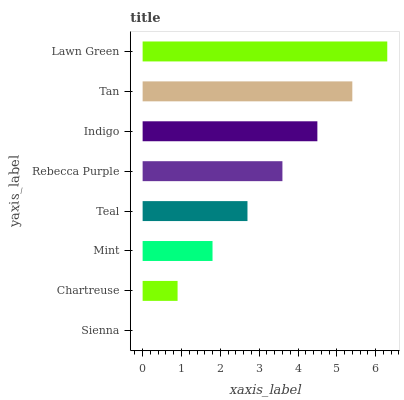Is Sienna the minimum?
Answer yes or no. Yes. Is Lawn Green the maximum?
Answer yes or no. Yes. Is Chartreuse the minimum?
Answer yes or no. No. Is Chartreuse the maximum?
Answer yes or no. No. Is Chartreuse greater than Sienna?
Answer yes or no. Yes. Is Sienna less than Chartreuse?
Answer yes or no. Yes. Is Sienna greater than Chartreuse?
Answer yes or no. No. Is Chartreuse less than Sienna?
Answer yes or no. No. Is Rebecca Purple the high median?
Answer yes or no. Yes. Is Teal the low median?
Answer yes or no. Yes. Is Indigo the high median?
Answer yes or no. No. Is Sienna the low median?
Answer yes or no. No. 